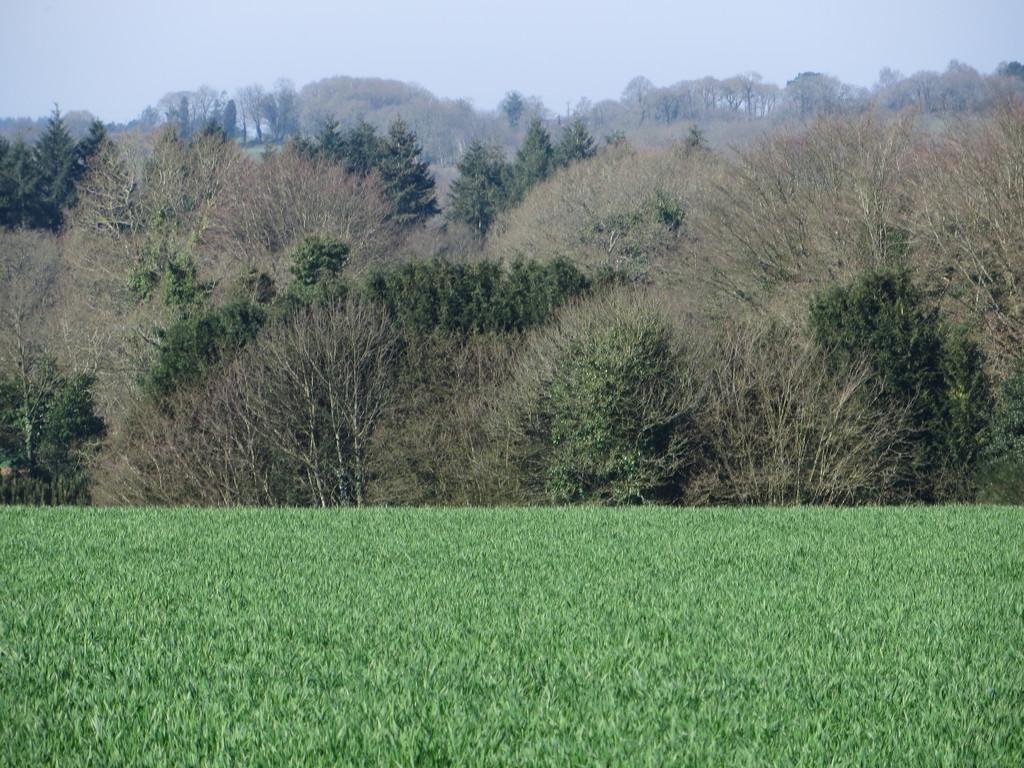What type of vegetation is in the foreground of the image? There is grass in the foreground of the image. What type of vegetation is in the background of the image? There are trees in the background of the image. What is visible at the top of the image? The sky is visible at the top of the image. What type of toothpaste is being used to destroy the trees in the image? There is no toothpaste or destruction present in the image. The image features grass in the foreground, trees in the background, and the sky visible at the top. 